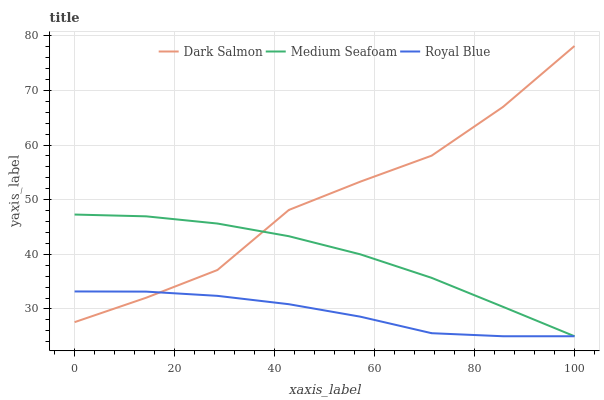Does Royal Blue have the minimum area under the curve?
Answer yes or no. Yes. Does Dark Salmon have the maximum area under the curve?
Answer yes or no. Yes. Does Medium Seafoam have the minimum area under the curve?
Answer yes or no. No. Does Medium Seafoam have the maximum area under the curve?
Answer yes or no. No. Is Medium Seafoam the smoothest?
Answer yes or no. Yes. Is Dark Salmon the roughest?
Answer yes or no. Yes. Is Dark Salmon the smoothest?
Answer yes or no. No. Is Medium Seafoam the roughest?
Answer yes or no. No. Does Royal Blue have the lowest value?
Answer yes or no. Yes. Does Dark Salmon have the lowest value?
Answer yes or no. No. Does Dark Salmon have the highest value?
Answer yes or no. Yes. Does Medium Seafoam have the highest value?
Answer yes or no. No. Does Medium Seafoam intersect Royal Blue?
Answer yes or no. Yes. Is Medium Seafoam less than Royal Blue?
Answer yes or no. No. Is Medium Seafoam greater than Royal Blue?
Answer yes or no. No. 